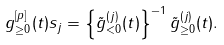<formula> <loc_0><loc_0><loc_500><loc_500>g ^ { [ p ] } _ { \geq 0 } ( t ) s _ { j } = \left \{ \tilde { g } ^ { ( j ) } _ { < 0 } ( t ) \right \} ^ { - 1 } \tilde { g } ^ { ( j ) } _ { \geq 0 } ( t ) .</formula> 